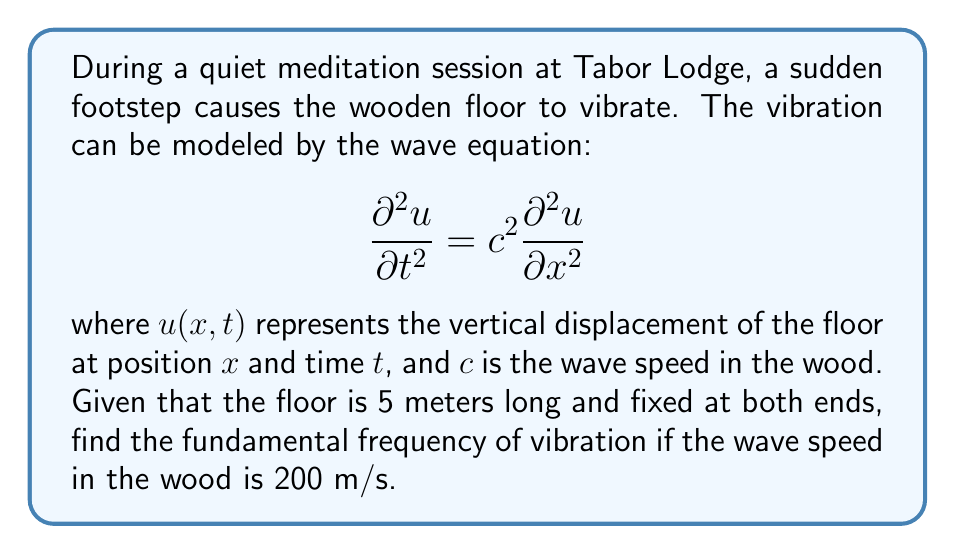Can you solve this math problem? To solve this problem, we'll follow these steps:

1) For a string (or in this case, a floor) fixed at both ends, the general solution to the wave equation is:

   $$u(x,t) = \sum_{n=1}^{\infty} A_n \sin(\frac{n\pi x}{L}) \cos(\frac{n\pi c t}{L})$$

   where $L$ is the length of the floor.

2) The fundamental frequency corresponds to $n=1$ in this solution.

3) The angular frequency $\omega$ for the fundamental mode is:

   $$\omega = \frac{\pi c}{L}$$

4) The frequency $f$ is related to the angular frequency by:

   $$f = \frac{\omega}{2\pi}$$

5) Substituting the given values:
   $L = 5$ m
   $c = 200$ m/s

6) Calculate the fundamental frequency:

   $$f = \frac{\omega}{2\pi} = \frac{\pi c}{2\pi L} = \frac{c}{2L} = \frac{200}{2(5)} = 20$$ Hz

Therefore, the fundamental frequency of vibration is 20 Hz.
Answer: 20 Hz 